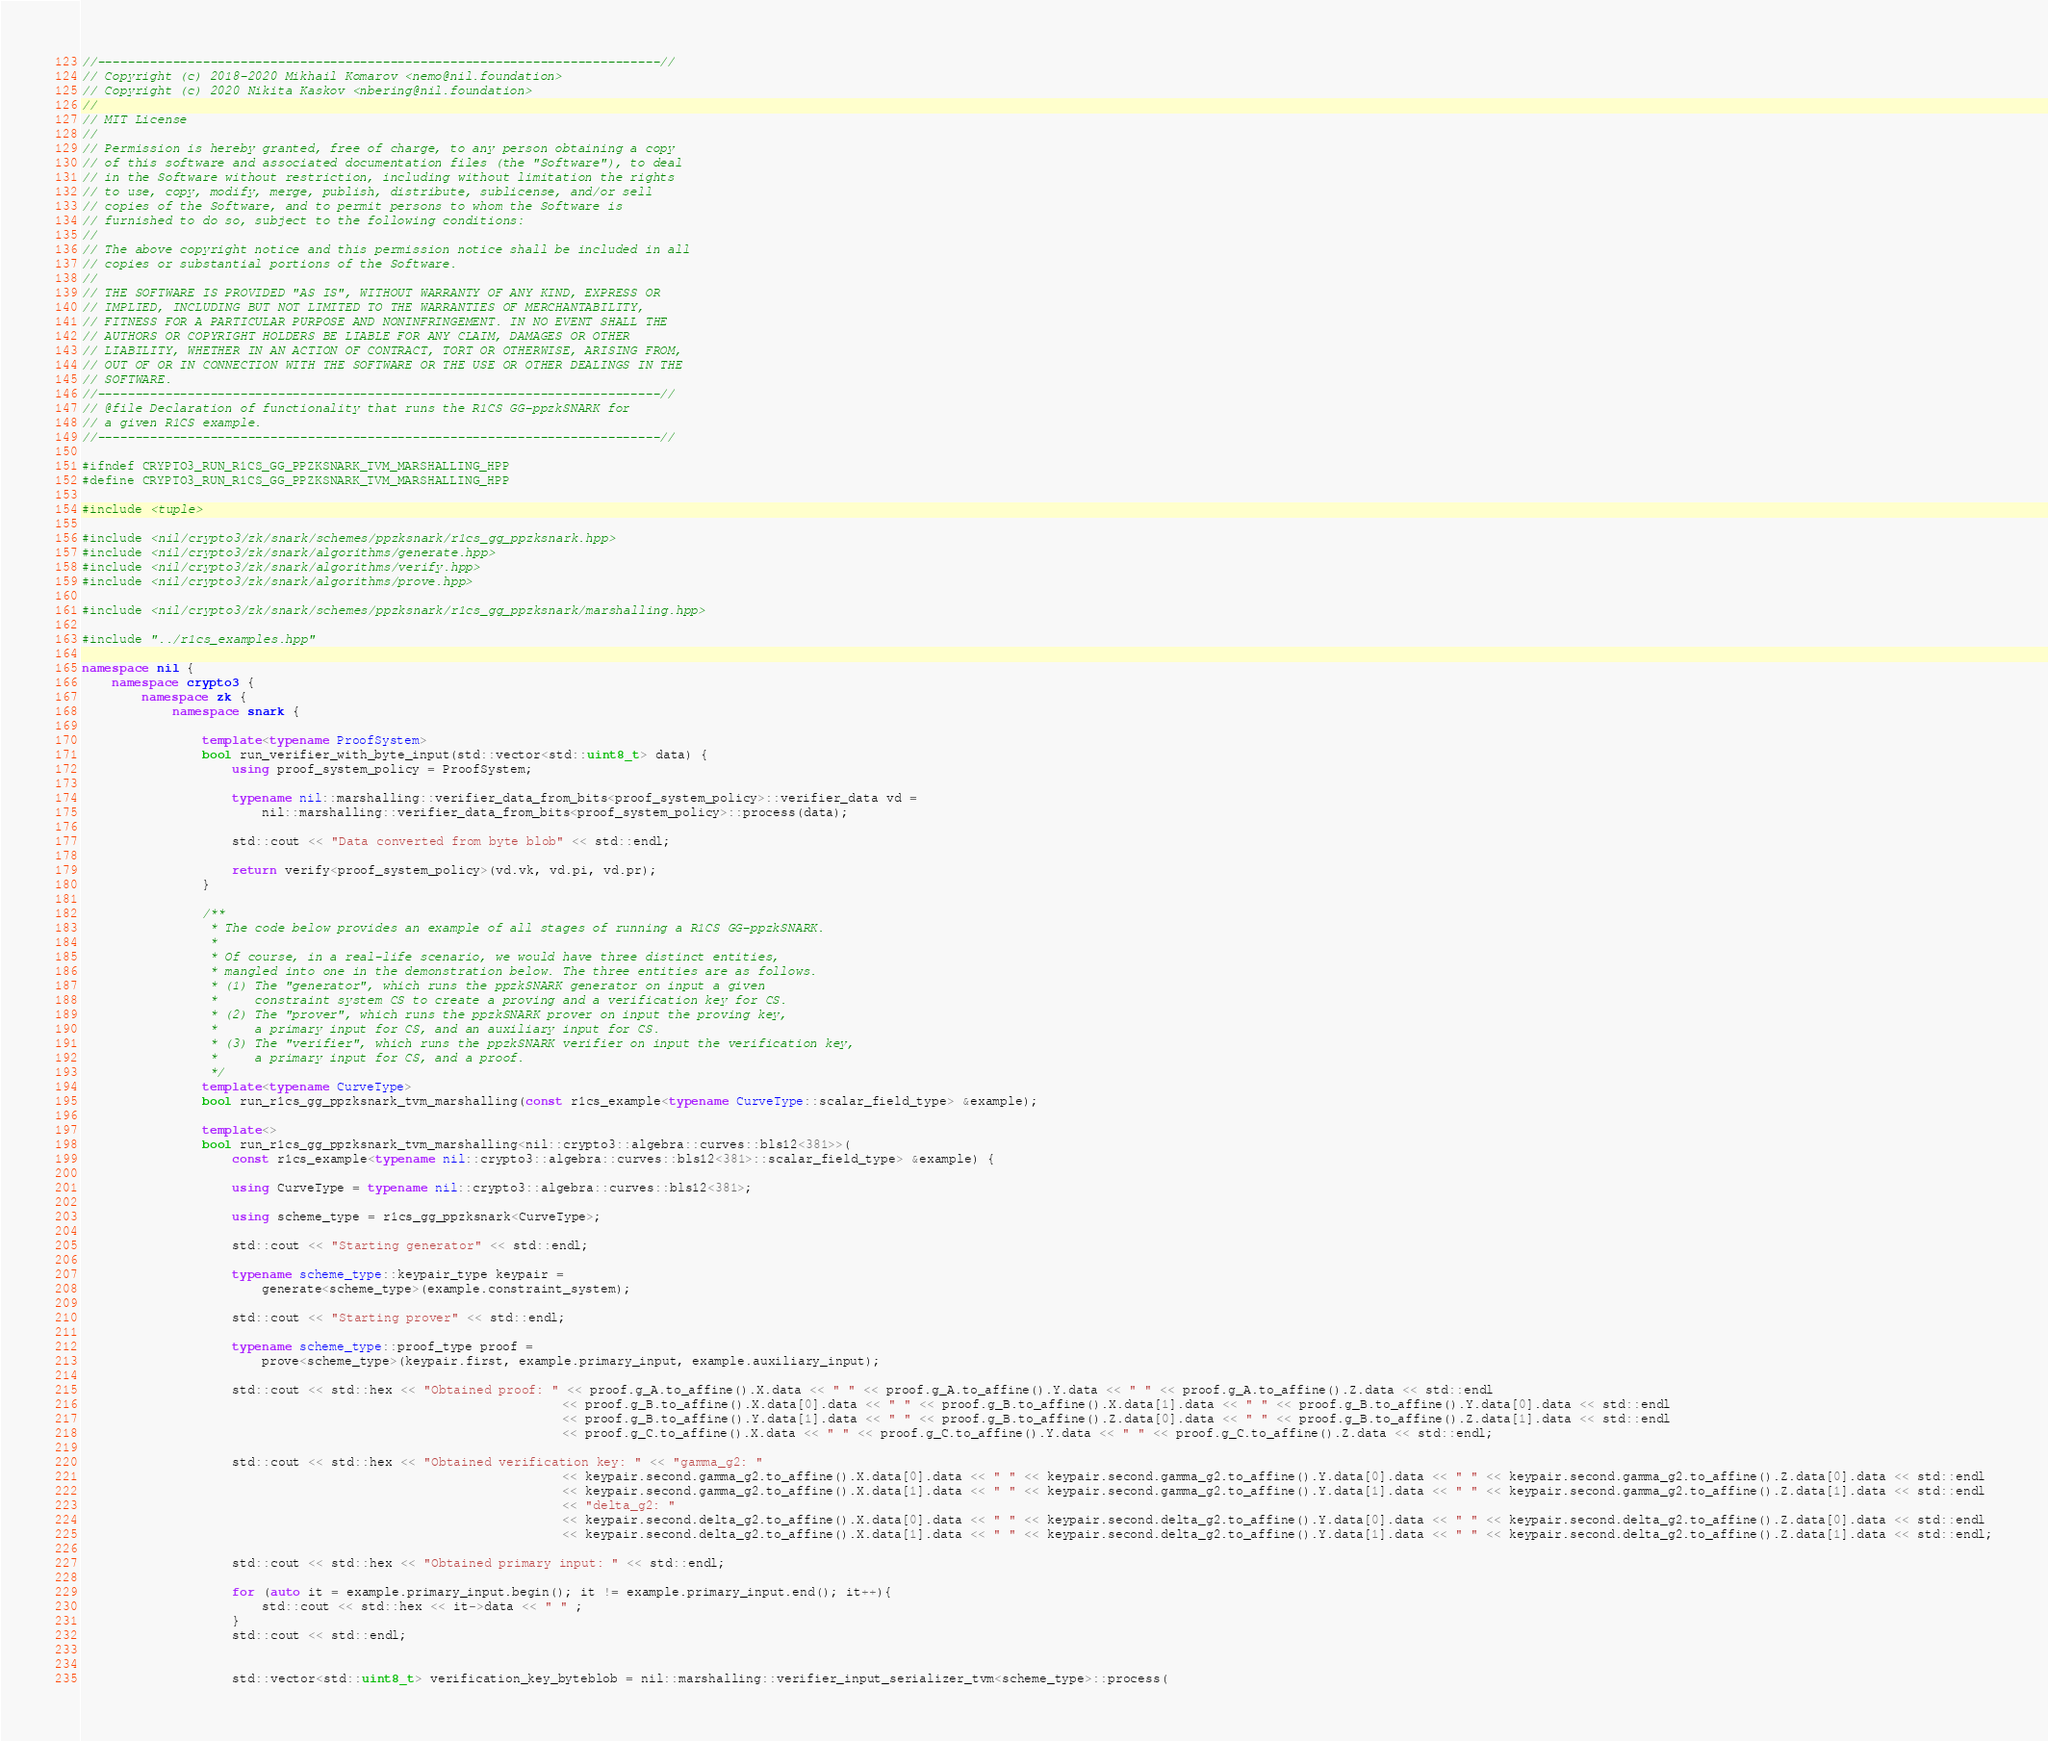Convert code to text. <code><loc_0><loc_0><loc_500><loc_500><_C++_>//---------------------------------------------------------------------------//
// Copyright (c) 2018-2020 Mikhail Komarov <nemo@nil.foundation>
// Copyright (c) 2020 Nikita Kaskov <nbering@nil.foundation>
//
// MIT License
//
// Permission is hereby granted, free of charge, to any person obtaining a copy
// of this software and associated documentation files (the "Software"), to deal
// in the Software without restriction, including without limitation the rights
// to use, copy, modify, merge, publish, distribute, sublicense, and/or sell
// copies of the Software, and to permit persons to whom the Software is
// furnished to do so, subject to the following conditions:
//
// The above copyright notice and this permission notice shall be included in all
// copies or substantial portions of the Software.
//
// THE SOFTWARE IS PROVIDED "AS IS", WITHOUT WARRANTY OF ANY KIND, EXPRESS OR
// IMPLIED, INCLUDING BUT NOT LIMITED TO THE WARRANTIES OF MERCHANTABILITY,
// FITNESS FOR A PARTICULAR PURPOSE AND NONINFRINGEMENT. IN NO EVENT SHALL THE
// AUTHORS OR COPYRIGHT HOLDERS BE LIABLE FOR ANY CLAIM, DAMAGES OR OTHER
// LIABILITY, WHETHER IN AN ACTION OF CONTRACT, TORT OR OTHERWISE, ARISING FROM,
// OUT OF OR IN CONNECTION WITH THE SOFTWARE OR THE USE OR OTHER DEALINGS IN THE
// SOFTWARE.
//---------------------------------------------------------------------------//
// @file Declaration of functionality that runs the R1CS GG-ppzkSNARK for
// a given R1CS example.
//---------------------------------------------------------------------------//

#ifndef CRYPTO3_RUN_R1CS_GG_PPZKSNARK_TVM_MARSHALLING_HPP
#define CRYPTO3_RUN_R1CS_GG_PPZKSNARK_TVM_MARSHALLING_HPP

#include <tuple>

#include <nil/crypto3/zk/snark/schemes/ppzksnark/r1cs_gg_ppzksnark.hpp>
#include <nil/crypto3/zk/snark/algorithms/generate.hpp>
#include <nil/crypto3/zk/snark/algorithms/verify.hpp>
#include <nil/crypto3/zk/snark/algorithms/prove.hpp>

#include <nil/crypto3/zk/snark/schemes/ppzksnark/r1cs_gg_ppzksnark/marshalling.hpp>

#include "../r1cs_examples.hpp"

namespace nil {
    namespace crypto3 {
        namespace zk {
            namespace snark {

                template<typename ProofSystem>
                bool run_verifier_with_byte_input(std::vector<std::uint8_t> data) {
                    using proof_system_policy = ProofSystem;

                    typename nil::marshalling::verifier_data_from_bits<proof_system_policy>::verifier_data vd =
                        nil::marshalling::verifier_data_from_bits<proof_system_policy>::process(data);

                    std::cout << "Data converted from byte blob" << std::endl;

                    return verify<proof_system_policy>(vd.vk, vd.pi, vd.pr);
                }

                /**
                 * The code below provides an example of all stages of running a R1CS GG-ppzkSNARK.
                 *
                 * Of course, in a real-life scenario, we would have three distinct entities,
                 * mangled into one in the demonstration below. The three entities are as follows.
                 * (1) The "generator", which runs the ppzkSNARK generator on input a given
                 *     constraint system CS to create a proving and a verification key for CS.
                 * (2) The "prover", which runs the ppzkSNARK prover on input the proving key,
                 *     a primary input for CS, and an auxiliary input for CS.
                 * (3) The "verifier", which runs the ppzkSNARK verifier on input the verification key,
                 *     a primary input for CS, and a proof.
                 */
                template<typename CurveType>
                bool run_r1cs_gg_ppzksnark_tvm_marshalling(const r1cs_example<typename CurveType::scalar_field_type> &example);

                template<>
                bool run_r1cs_gg_ppzksnark_tvm_marshalling<nil::crypto3::algebra::curves::bls12<381>>(
                    const r1cs_example<typename nil::crypto3::algebra::curves::bls12<381>::scalar_field_type> &example) {

                    using CurveType = typename nil::crypto3::algebra::curves::bls12<381>;

                    using scheme_type = r1cs_gg_ppzksnark<CurveType>;

                    std::cout << "Starting generator" << std::endl;

                    typename scheme_type::keypair_type keypair =
                        generate<scheme_type>(example.constraint_system);

                    std::cout << "Starting prover" << std::endl;

                    typename scheme_type::proof_type proof =
                        prove<scheme_type>(keypair.first, example.primary_input, example.auxiliary_input);

                    std::cout << std::hex << "Obtained proof: " << proof.g_A.to_affine().X.data << " " << proof.g_A.to_affine().Y.data << " " << proof.g_A.to_affine().Z.data << std::endl
                                                                << proof.g_B.to_affine().X.data[0].data << " " << proof.g_B.to_affine().X.data[1].data << " " << proof.g_B.to_affine().Y.data[0].data << std::endl
                                                                << proof.g_B.to_affine().Y.data[1].data << " " << proof.g_B.to_affine().Z.data[0].data << " " << proof.g_B.to_affine().Z.data[1].data << std::endl
                                                                << proof.g_C.to_affine().X.data << " " << proof.g_C.to_affine().Y.data << " " << proof.g_C.to_affine().Z.data << std::endl;

                    std::cout << std::hex << "Obtained verification key: " << "gamma_g2: " 
                                                                << keypair.second.gamma_g2.to_affine().X.data[0].data << " " << keypair.second.gamma_g2.to_affine().Y.data[0].data << " " << keypair.second.gamma_g2.to_affine().Z.data[0].data << std::endl
                                                                << keypair.second.gamma_g2.to_affine().X.data[1].data << " " << keypair.second.gamma_g2.to_affine().Y.data[1].data << " " << keypair.second.gamma_g2.to_affine().Z.data[1].data << std::endl
                                                                << "delta_g2: " 
                                                                << keypair.second.delta_g2.to_affine().X.data[0].data << " " << keypair.second.delta_g2.to_affine().Y.data[0].data << " " << keypair.second.delta_g2.to_affine().Z.data[0].data << std::endl
                                                                << keypair.second.delta_g2.to_affine().X.data[1].data << " " << keypair.second.delta_g2.to_affine().Y.data[1].data << " " << keypair.second.delta_g2.to_affine().Z.data[1].data << std::endl;

                    std::cout << std::hex << "Obtained primary input: " << std::endl;

                    for (auto it = example.primary_input.begin(); it != example.primary_input.end(); it++){
                        std::cout << std::hex << it->data << " " ;
                    }
                    std::cout << std::endl;


                    std::vector<std::uint8_t> verification_key_byteblob = nil::marshalling::verifier_input_serializer_tvm<scheme_type>::process(</code> 